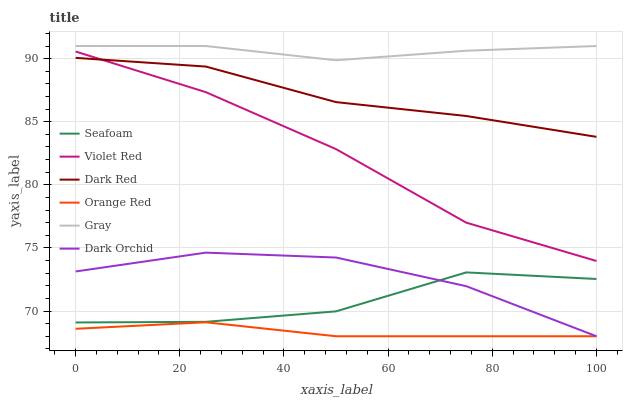Does Orange Red have the minimum area under the curve?
Answer yes or no. Yes. Does Gray have the maximum area under the curve?
Answer yes or no. Yes. Does Violet Red have the minimum area under the curve?
Answer yes or no. No. Does Violet Red have the maximum area under the curve?
Answer yes or no. No. Is Orange Red the smoothest?
Answer yes or no. Yes. Is Seafoam the roughest?
Answer yes or no. Yes. Is Violet Red the smoothest?
Answer yes or no. No. Is Violet Red the roughest?
Answer yes or no. No. Does Dark Orchid have the lowest value?
Answer yes or no. Yes. Does Violet Red have the lowest value?
Answer yes or no. No. Does Gray have the highest value?
Answer yes or no. Yes. Does Violet Red have the highest value?
Answer yes or no. No. Is Dark Orchid less than Gray?
Answer yes or no. Yes. Is Dark Red greater than Dark Orchid?
Answer yes or no. Yes. Does Dark Orchid intersect Seafoam?
Answer yes or no. Yes. Is Dark Orchid less than Seafoam?
Answer yes or no. No. Is Dark Orchid greater than Seafoam?
Answer yes or no. No. Does Dark Orchid intersect Gray?
Answer yes or no. No. 